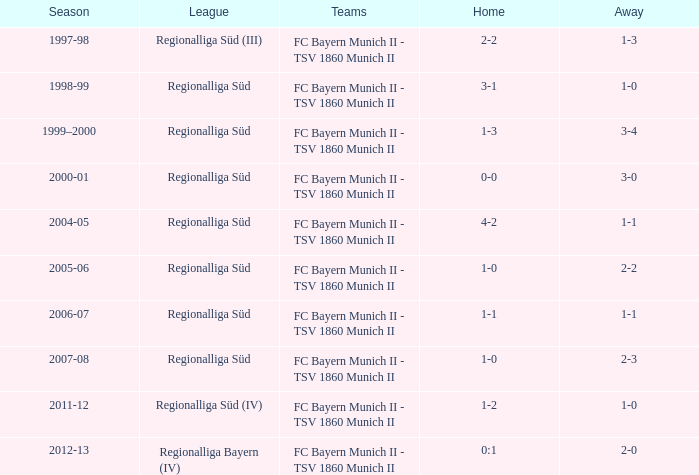What season has a regionalliga süd league, a 1-0 home, and an away of 2-3? 2007-08. 